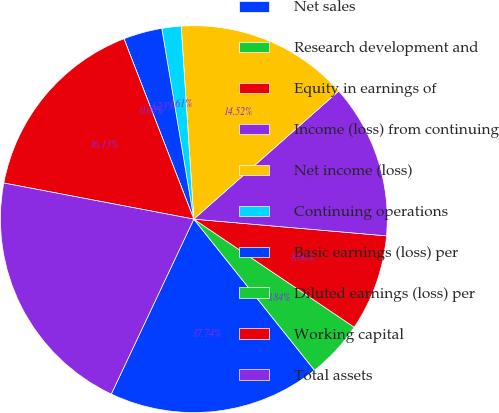<chart> <loc_0><loc_0><loc_500><loc_500><pie_chart><fcel>Net sales<fcel>Research development and<fcel>Equity in earnings of<fcel>Income (loss) from continuing<fcel>Net income (loss)<fcel>Continuing operations<fcel>Basic earnings (loss) per<fcel>Diluted earnings (loss) per<fcel>Working capital<fcel>Total assets<nl><fcel>17.74%<fcel>4.84%<fcel>8.06%<fcel>12.9%<fcel>14.52%<fcel>1.61%<fcel>3.23%<fcel>0.0%<fcel>16.13%<fcel>20.97%<nl></chart> 